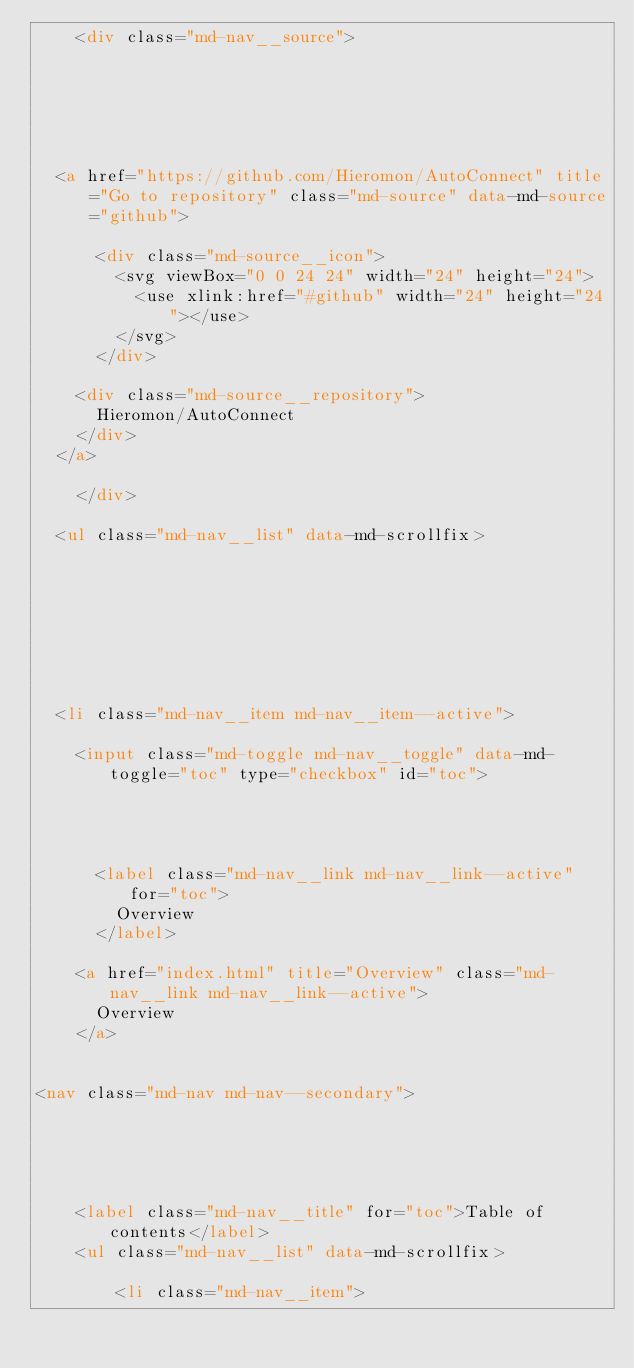Convert code to text. <code><loc_0><loc_0><loc_500><loc_500><_HTML_>    <div class="md-nav__source">
      


  


  <a href="https://github.com/Hieromon/AutoConnect" title="Go to repository" class="md-source" data-md-source="github">
    
      <div class="md-source__icon">
        <svg viewBox="0 0 24 24" width="24" height="24">
          <use xlink:href="#github" width="24" height="24"></use>
        </svg>
      </div>
    
    <div class="md-source__repository">
      Hieromon/AutoConnect
    </div>
  </a>

    </div>
  
  <ul class="md-nav__list" data-md-scrollfix>
    
      
      
      

  


  <li class="md-nav__item md-nav__item--active">
    
    <input class="md-toggle md-nav__toggle" data-md-toggle="toc" type="checkbox" id="toc">
    
      
    
    
      <label class="md-nav__link md-nav__link--active" for="toc">
        Overview
      </label>
    
    <a href="index.html" title="Overview" class="md-nav__link md-nav__link--active">
      Overview
    </a>
    
      
<nav class="md-nav md-nav--secondary">
  
  
    
  
  
    <label class="md-nav__title" for="toc">Table of contents</label>
    <ul class="md-nav__list" data-md-scrollfix>
      
        <li class="md-nav__item"></code> 